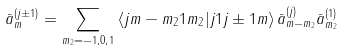Convert formula to latex. <formula><loc_0><loc_0><loc_500><loc_500>\bar { a } _ { m } ^ { \left ( j \pm 1 \right ) } = \sum _ { m _ { 2 } = - 1 , 0 , 1 } \left \langle j m - m _ { 2 } 1 m _ { 2 } | j 1 j \pm 1 m \right \rangle \bar { a } _ { m - m _ { 2 } } ^ { \left ( j \right ) } \bar { a } _ { m _ { 2 } } ^ { \left ( 1 \right ) }</formula> 